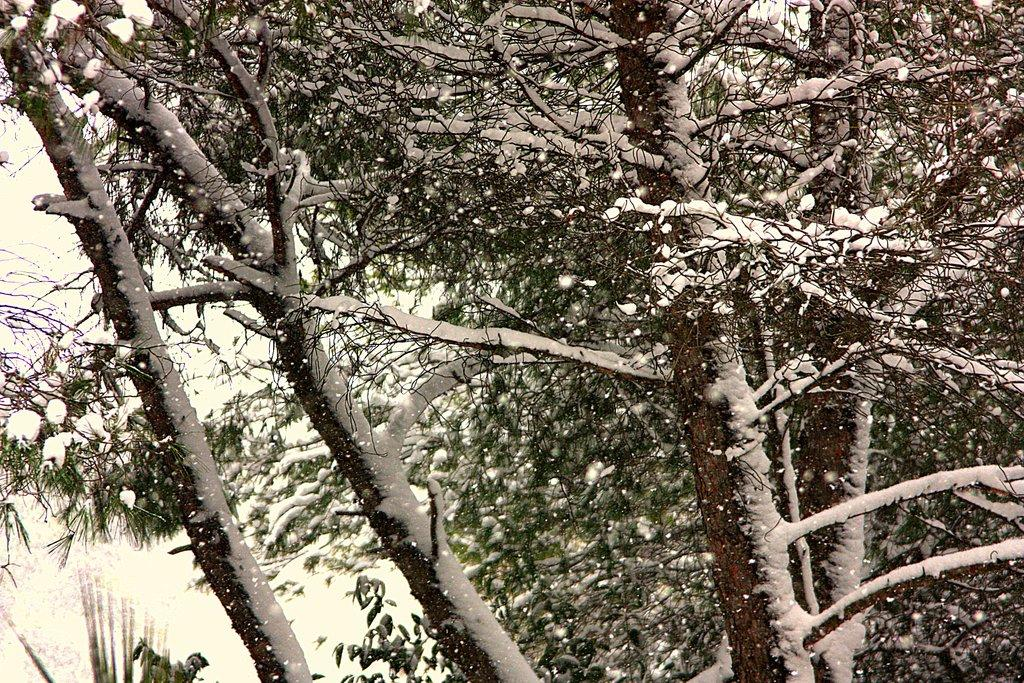What type of vegetation can be seen in the image? There are trees in the image. What is covering the trees in the image? The trees have snow on them. What type of needle is used to sew the pie in the image? There is no pie or needle present in the image; it only features trees with snow on them. 